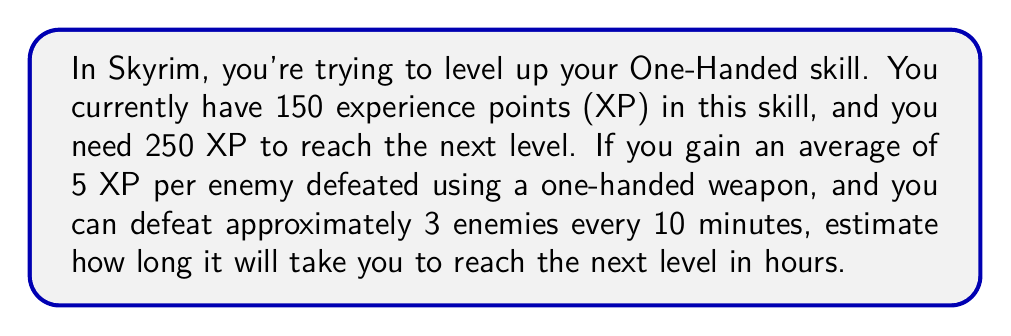Can you solve this math problem? Let's break this problem down step-by-step:

1. Calculate the XP needed to level up:
   $$ \text{XP needed} = 250 - 150 = 100 \text{ XP} $$

2. Calculate the number of enemies needed to defeat:
   $$ \text{Enemies needed} = \frac{\text{XP needed}}{\text{XP per enemy}} = \frac{100}{5} = 20 \text{ enemies} $$

3. Calculate the time needed to defeat these enemies:
   - We know you can defeat 3 enemies every 10 minutes
   - So, we need to find out how many 10-minute intervals are needed:
     $$ \text{Number of 10-minute intervals} = \frac{\text{Enemies needed}}{\text{Enemies per 10 minutes}} = \frac{20}{3} \approx 6.67 $$

4. Convert the number of 10-minute intervals to minutes:
   $$ \text{Total minutes} = 6.67 \times 10 = 66.7 \text{ minutes} $$

5. Convert minutes to hours:
   $$ \text{Hours} = \frac{\text{Total minutes}}{60} = \frac{66.7}{60} \approx 1.11 \text{ hours} $$

Therefore, it will take approximately 1.11 hours to reach the next level in the One-Handed skill.
Answer: $1.11 \text{ hours}$ 